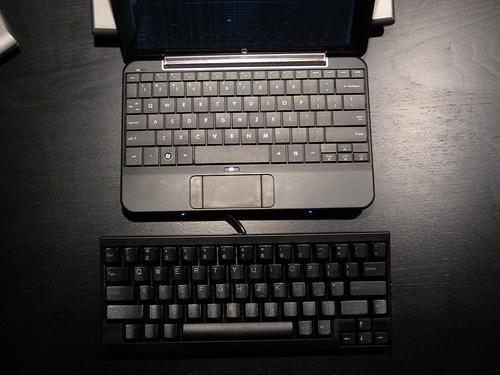How many keyboards are there?
Give a very brief answer. 2. How many screens are there?
Give a very brief answer. 1. 